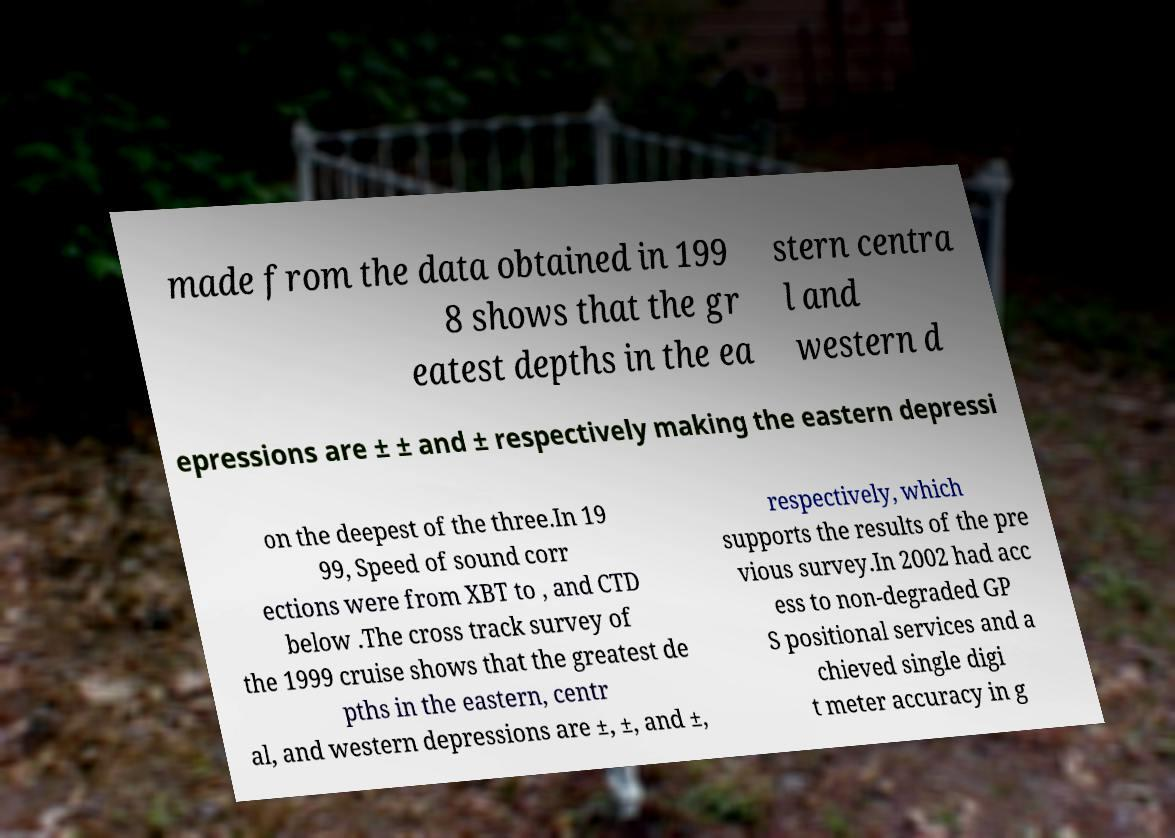For documentation purposes, I need the text within this image transcribed. Could you provide that? made from the data obtained in 199 8 shows that the gr eatest depths in the ea stern centra l and western d epressions are ± ± and ± respectively making the eastern depressi on the deepest of the three.In 19 99, Speed of sound corr ections were from XBT to , and CTD below .The cross track survey of the 1999 cruise shows that the greatest de pths in the eastern, centr al, and western depressions are ±, ±, and ±, respectively, which supports the results of the pre vious survey.In 2002 had acc ess to non-degraded GP S positional services and a chieved single digi t meter accuracy in g 